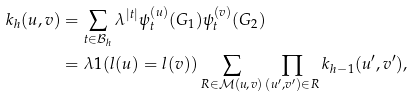Convert formula to latex. <formula><loc_0><loc_0><loc_500><loc_500>k _ { h } ( u , v ) & = \sum _ { t \in \mathcal { B } _ { h } } \lambda ^ { | t | } \psi ^ { ( u ) } _ { t } ( G _ { 1 } ) \psi ^ { ( v ) } _ { t } ( G _ { 2 } ) \\ & = \lambda { 1 } ( l ( u ) = l ( v ) ) \sum _ { R \in \mathcal { M } ( u , v ) } \prod _ { ( u ^ { \prime } , v ^ { \prime } ) \in R } k _ { h - 1 } ( u ^ { \prime } , v ^ { \prime } ) ,</formula> 